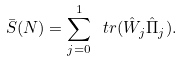<formula> <loc_0><loc_0><loc_500><loc_500>\bar { S } ( N ) = \sum _ { j = 0 } ^ { 1 } \ t r { ( \hat { W } _ { j } \hat { \Pi } _ { j } ) } .</formula> 